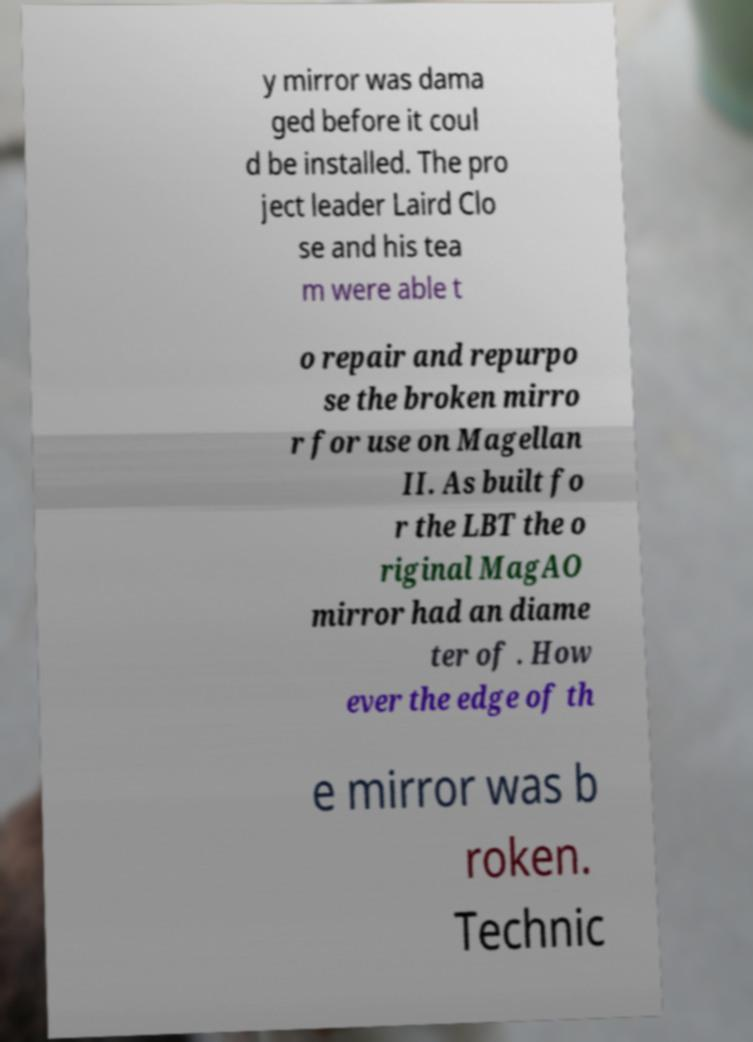For documentation purposes, I need the text within this image transcribed. Could you provide that? y mirror was dama ged before it coul d be installed. The pro ject leader Laird Clo se and his tea m were able t o repair and repurpo se the broken mirro r for use on Magellan II. As built fo r the LBT the o riginal MagAO mirror had an diame ter of . How ever the edge of th e mirror was b roken. Technic 